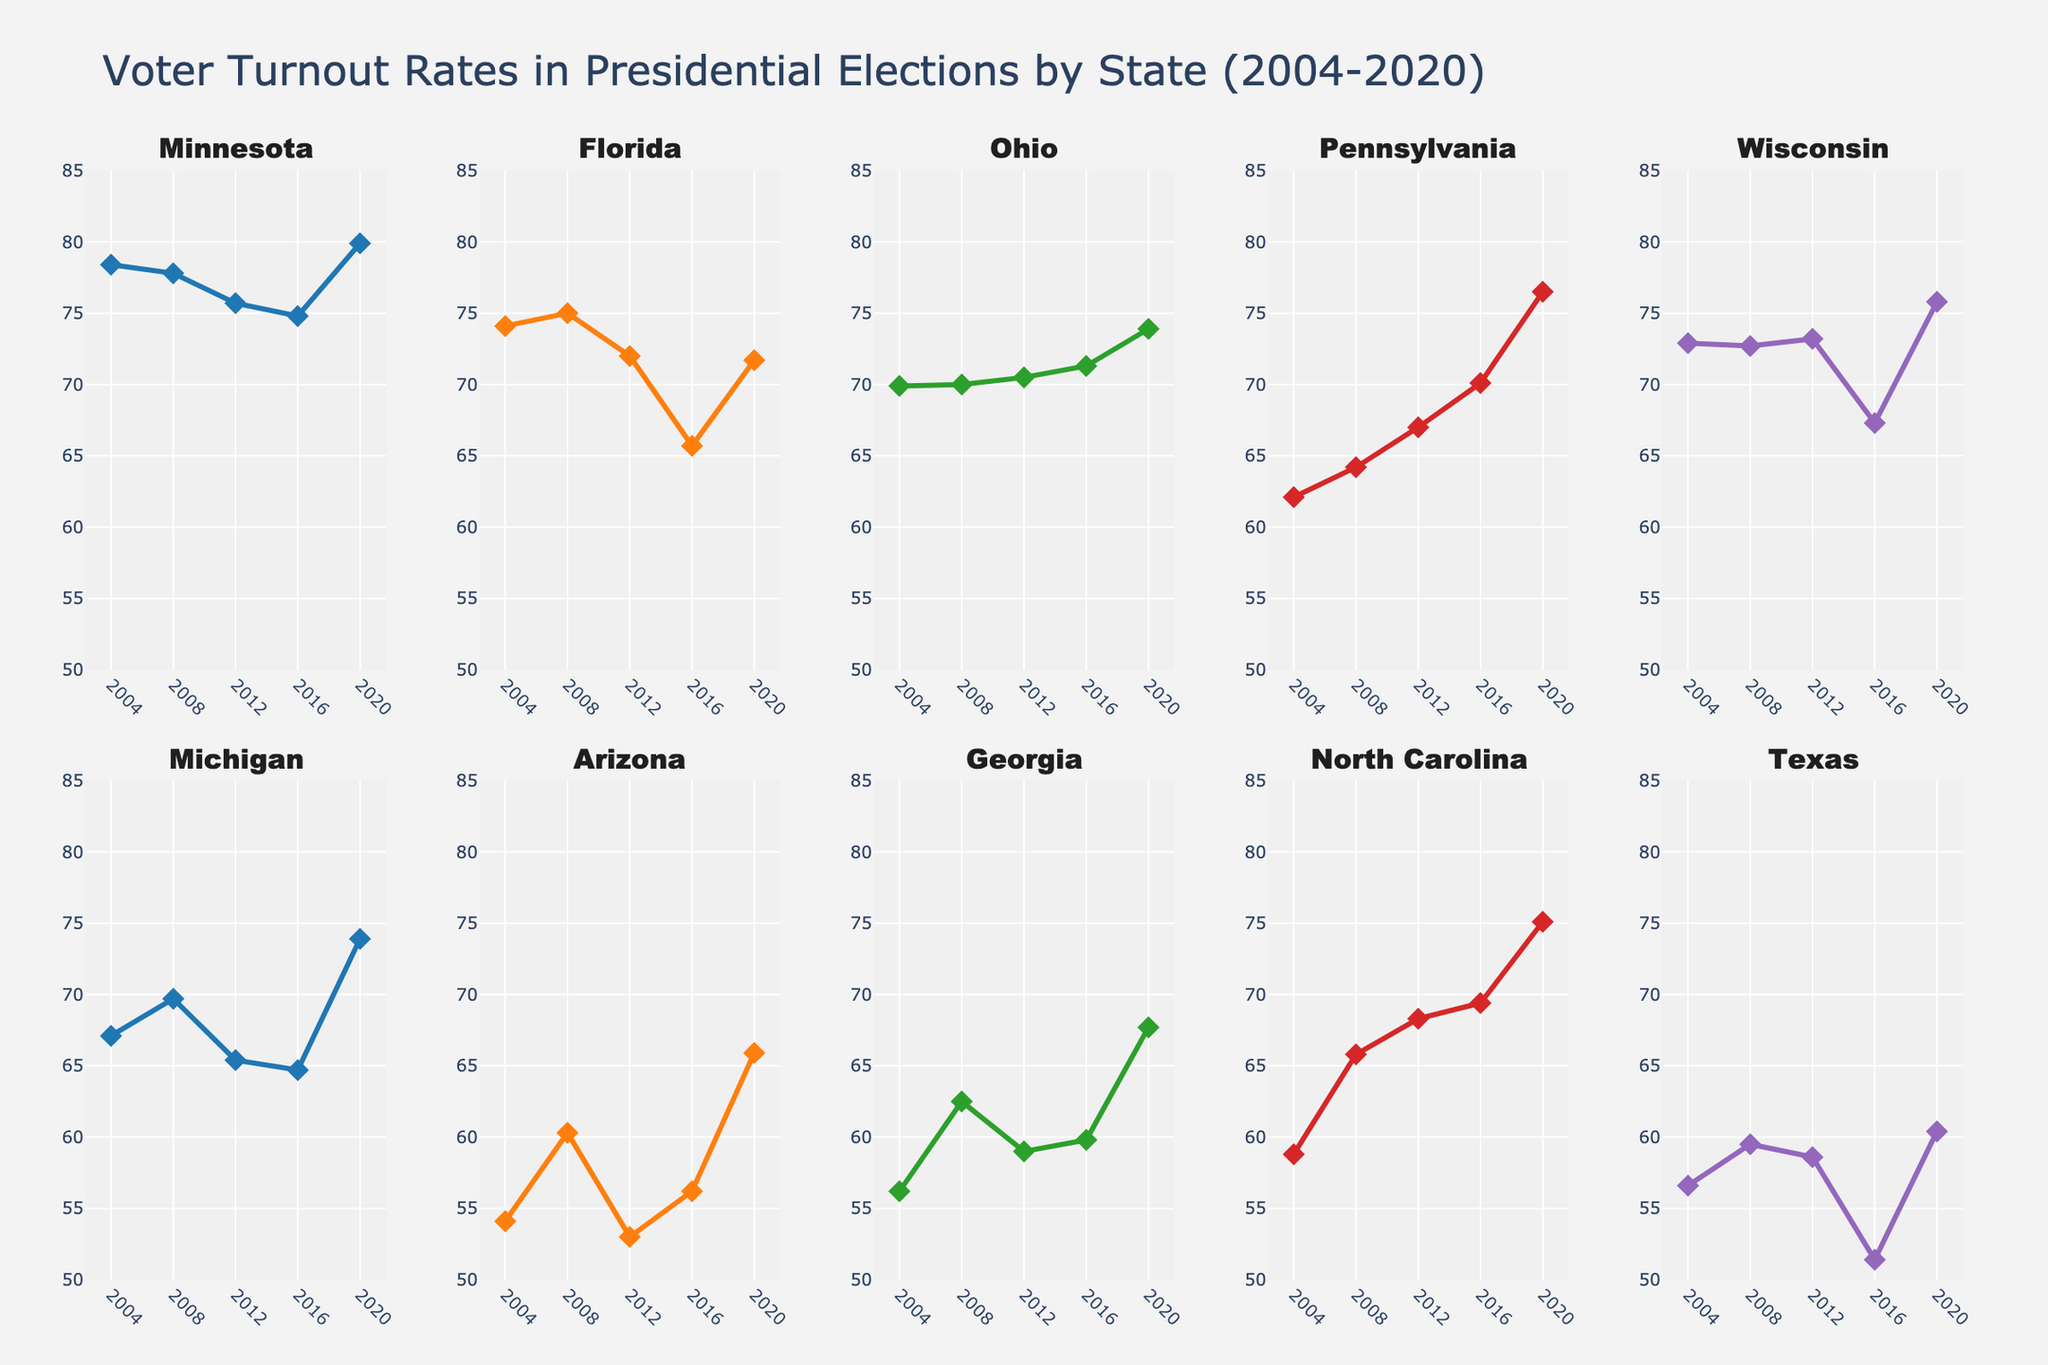Which year had the highest severity of cybersecurity incidents? The severity plot in the top subplot shows a peak at 2017 with a severity score of 10
Answer: 2017 How many banks experienced cybersecurity incidents in 2022 and 2023 combined? In the second subplot (Impacted Accounts), the bars for 2022 and 2023 are distinct and show incidents for 1 bank each year. Adding these gives 1 (2022) + 1 (2023) = 2
Answer: 2 Which bank had the largest number of impacted accounts over the past decade? By examining the heights of the bars in the "Impacted Accounts" subplot, the highest bar is in 2019 corresponding to Capital One with 100,000,000 impacted accounts
Answer: Capital One What was the total number of impacted accounts in incidents with a severity level of 8? Severity level of 8 occurred in 2014 (Home Depot, 56,000,000) and 2019 (Capital One, 100,000,000). Summing these: 56,000,000 + 100,000,000 = 156,000,000
Answer: 156,000,000 Compare the number of impacted accounts between 2013 and 2017. Which year had more and by how much? In the "Impacted Accounts" subplot, 2013 (JPMorgan Chase, 76,000,000) and 2017 (Equifax, 147,000,000). The difference is 147,000,000 - 76,000,000 = 71,000,000. 2017 had more by 71,000,000
Answer: 2017, by 71,000,000 Is the number of impacted accounts lower in incidents with severity less than 7 compared to those with severity greater than 7? Severity less than 7: 2022 (8,200,000), 2021 (1,474,000), 2018 (1,500,000) summing gives 8,200,000 + 1,474,000 + 1,500,000 = 11,174,000. Severity greater than 7: 2014 (56,000,000), 2016 (81,000,000), 2017 (147,000,000), 2019 (100,000,000), 2023 (9,700,000) summing gives 393,700,000. Comparing: 11,174,000 is less than 393,700,000
Answer: Yes, it is lower What is the average severity score of incidents from 2018 to 2021? Severity scores for these years: 2018 (6), 2019 (8), 2020 (7), and 2021 (6). Total is 6 + 8 + 7 + 6 = 27. Average = 27 / 4 = 6.75
Answer: 6.75 Which year saw the least severe cybersecurity incident, and what was its severity? From the severity plot, the lowest severity score is in 2022 with a value of 5
Answer: 2022, with severity 5 Did the severity of incidents show any noticeable trends over the years? Observing the severity plot, severity fluctuates with peaks (e.g., 2017) and troughs (e.g., 2022), no consistent increase or decrease
Answer: No consistent trend How many times did a bank experience a cybersecurity incident with a severity of 9? From the severity plot, score 9 appears in 2016 (SWIFT) and 2023 (Medibank). This occurred 2 times
Answer: 2 